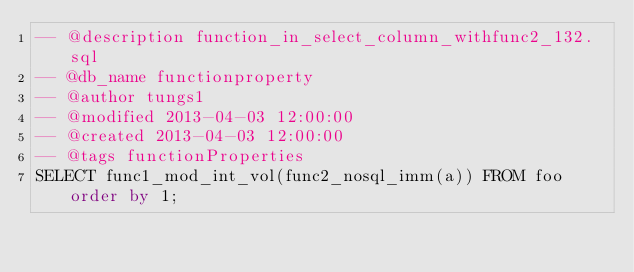<code> <loc_0><loc_0><loc_500><loc_500><_SQL_>-- @description function_in_select_column_withfunc2_132.sql
-- @db_name functionproperty
-- @author tungs1
-- @modified 2013-04-03 12:00:00
-- @created 2013-04-03 12:00:00
-- @tags functionProperties 
SELECT func1_mod_int_vol(func2_nosql_imm(a)) FROM foo order by 1; 
</code> 